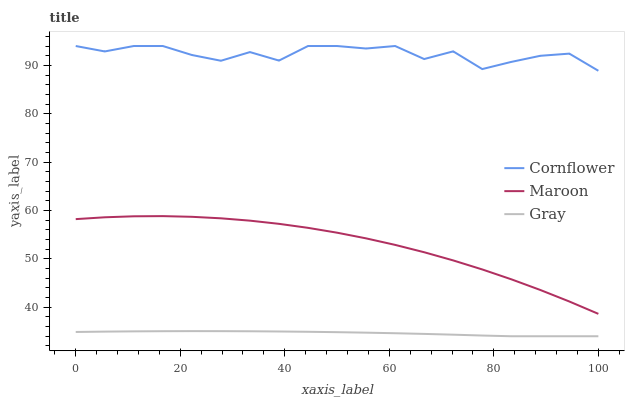Does Gray have the minimum area under the curve?
Answer yes or no. Yes. Does Cornflower have the maximum area under the curve?
Answer yes or no. Yes. Does Maroon have the minimum area under the curve?
Answer yes or no. No. Does Maroon have the maximum area under the curve?
Answer yes or no. No. Is Gray the smoothest?
Answer yes or no. Yes. Is Cornflower the roughest?
Answer yes or no. Yes. Is Maroon the smoothest?
Answer yes or no. No. Is Maroon the roughest?
Answer yes or no. No. Does Gray have the lowest value?
Answer yes or no. Yes. Does Maroon have the lowest value?
Answer yes or no. No. Does Cornflower have the highest value?
Answer yes or no. Yes. Does Maroon have the highest value?
Answer yes or no. No. Is Maroon less than Cornflower?
Answer yes or no. Yes. Is Cornflower greater than Maroon?
Answer yes or no. Yes. Does Maroon intersect Cornflower?
Answer yes or no. No. 